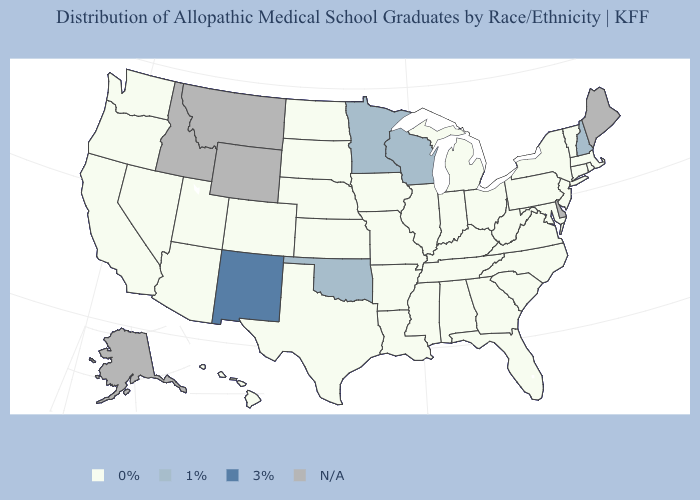Among the states that border Delaware , which have the lowest value?
Short answer required. Maryland, New Jersey, Pennsylvania. What is the lowest value in the Northeast?
Be succinct. 0%. Which states hav the highest value in the MidWest?
Be succinct. Minnesota, Wisconsin. Which states have the lowest value in the MidWest?
Be succinct. Illinois, Indiana, Iowa, Kansas, Michigan, Missouri, Nebraska, North Dakota, Ohio, South Dakota. Name the states that have a value in the range 0%?
Be succinct. Alabama, Arizona, Arkansas, California, Colorado, Connecticut, Florida, Georgia, Hawaii, Illinois, Indiana, Iowa, Kansas, Kentucky, Louisiana, Maryland, Massachusetts, Michigan, Mississippi, Missouri, Nebraska, Nevada, New Jersey, New York, North Carolina, North Dakota, Ohio, Oregon, Pennsylvania, Rhode Island, South Carolina, South Dakota, Tennessee, Texas, Utah, Vermont, Virginia, Washington, West Virginia. Which states have the lowest value in the MidWest?
Be succinct. Illinois, Indiana, Iowa, Kansas, Michigan, Missouri, Nebraska, North Dakota, Ohio, South Dakota. What is the lowest value in the USA?
Quick response, please. 0%. Does Washington have the lowest value in the West?
Give a very brief answer. Yes. Is the legend a continuous bar?
Concise answer only. No. Name the states that have a value in the range 0%?
Concise answer only. Alabama, Arizona, Arkansas, California, Colorado, Connecticut, Florida, Georgia, Hawaii, Illinois, Indiana, Iowa, Kansas, Kentucky, Louisiana, Maryland, Massachusetts, Michigan, Mississippi, Missouri, Nebraska, Nevada, New Jersey, New York, North Carolina, North Dakota, Ohio, Oregon, Pennsylvania, Rhode Island, South Carolina, South Dakota, Tennessee, Texas, Utah, Vermont, Virginia, Washington, West Virginia. What is the value of Washington?
Quick response, please. 0%. Does Mississippi have the highest value in the South?
Give a very brief answer. No. Does Massachusetts have the highest value in the USA?
Keep it brief. No. 